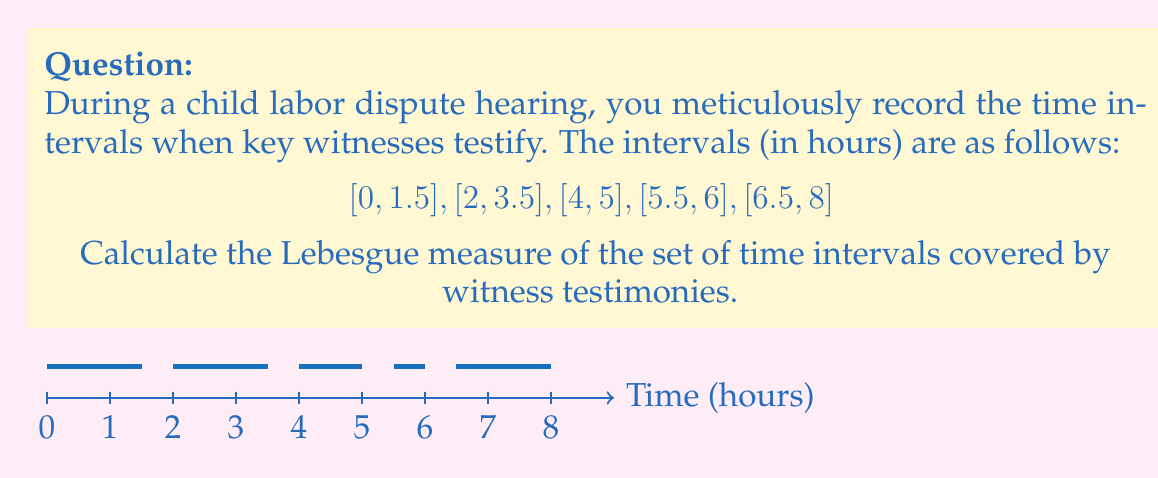Give your solution to this math problem. To calculate the Lebesgue measure of the set of time intervals, we need to sum up the lengths of the non-overlapping intervals. This is equivalent to finding the total time covered by witness testimonies.

Let's break it down step-by-step:

1) First, let's list out the intervals and their individual lengths:
   [0, 1.5]: length = 1.5 - 0 = 1.5 hours
   [2, 3.5]: length = 3.5 - 2 = 1.5 hours
   [4, 5]: length = 5 - 4 = 1 hour
   [5.5, 6]: length = 6 - 5.5 = 0.5 hours
   [6.5, 8]: length = 8 - 6.5 = 1.5 hours

2) Now, we simply need to sum these lengths:

   $$ \text{Lebesgue measure} = 1.5 + 1.5 + 1 + 0.5 + 1.5 $$

3) Calculating the sum:

   $$ \text{Lebesgue measure} = 6 \text{ hours} $$

The Lebesgue measure of a set of intervals on the real line is equivalent to the sum of the lengths of these intervals when they are non-overlapping, which is the case here.
Answer: 6 hours 